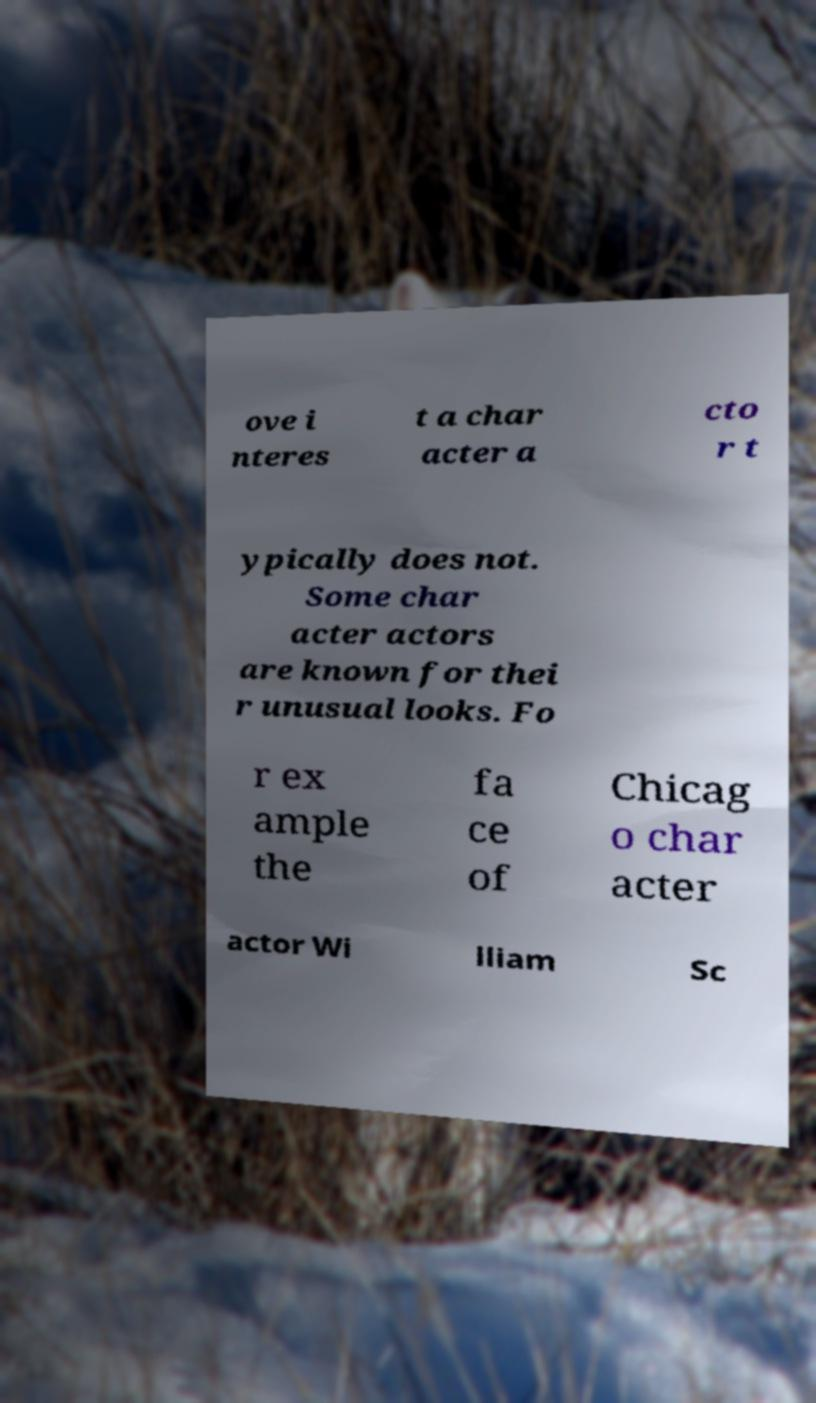Could you assist in decoding the text presented in this image and type it out clearly? ove i nteres t a char acter a cto r t ypically does not. Some char acter actors are known for thei r unusual looks. Fo r ex ample the fa ce of Chicag o char acter actor Wi lliam Sc 